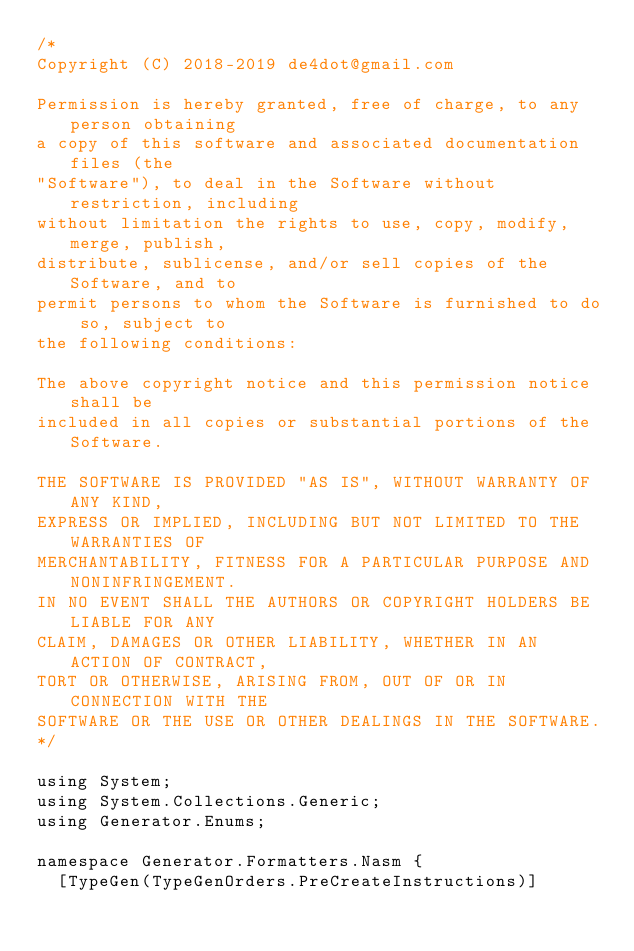Convert code to text. <code><loc_0><loc_0><loc_500><loc_500><_C#_>/*
Copyright (C) 2018-2019 de4dot@gmail.com

Permission is hereby granted, free of charge, to any person obtaining
a copy of this software and associated documentation files (the
"Software"), to deal in the Software without restriction, including
without limitation the rights to use, copy, modify, merge, publish,
distribute, sublicense, and/or sell copies of the Software, and to
permit persons to whom the Software is furnished to do so, subject to
the following conditions:

The above copyright notice and this permission notice shall be
included in all copies or substantial portions of the Software.

THE SOFTWARE IS PROVIDED "AS IS", WITHOUT WARRANTY OF ANY KIND,
EXPRESS OR IMPLIED, INCLUDING BUT NOT LIMITED TO THE WARRANTIES OF
MERCHANTABILITY, FITNESS FOR A PARTICULAR PURPOSE AND NONINFRINGEMENT.
IN NO EVENT SHALL THE AUTHORS OR COPYRIGHT HOLDERS BE LIABLE FOR ANY
CLAIM, DAMAGES OR OTHER LIABILITY, WHETHER IN AN ACTION OF CONTRACT,
TORT OR OTHERWISE, ARISING FROM, OUT OF OR IN CONNECTION WITH THE
SOFTWARE OR THE USE OR OTHER DEALINGS IN THE SOFTWARE.
*/

using System;
using System.Collections.Generic;
using Generator.Enums;

namespace Generator.Formatters.Nasm {
	[TypeGen(TypeGenOrders.PreCreateInstructions)]</code> 